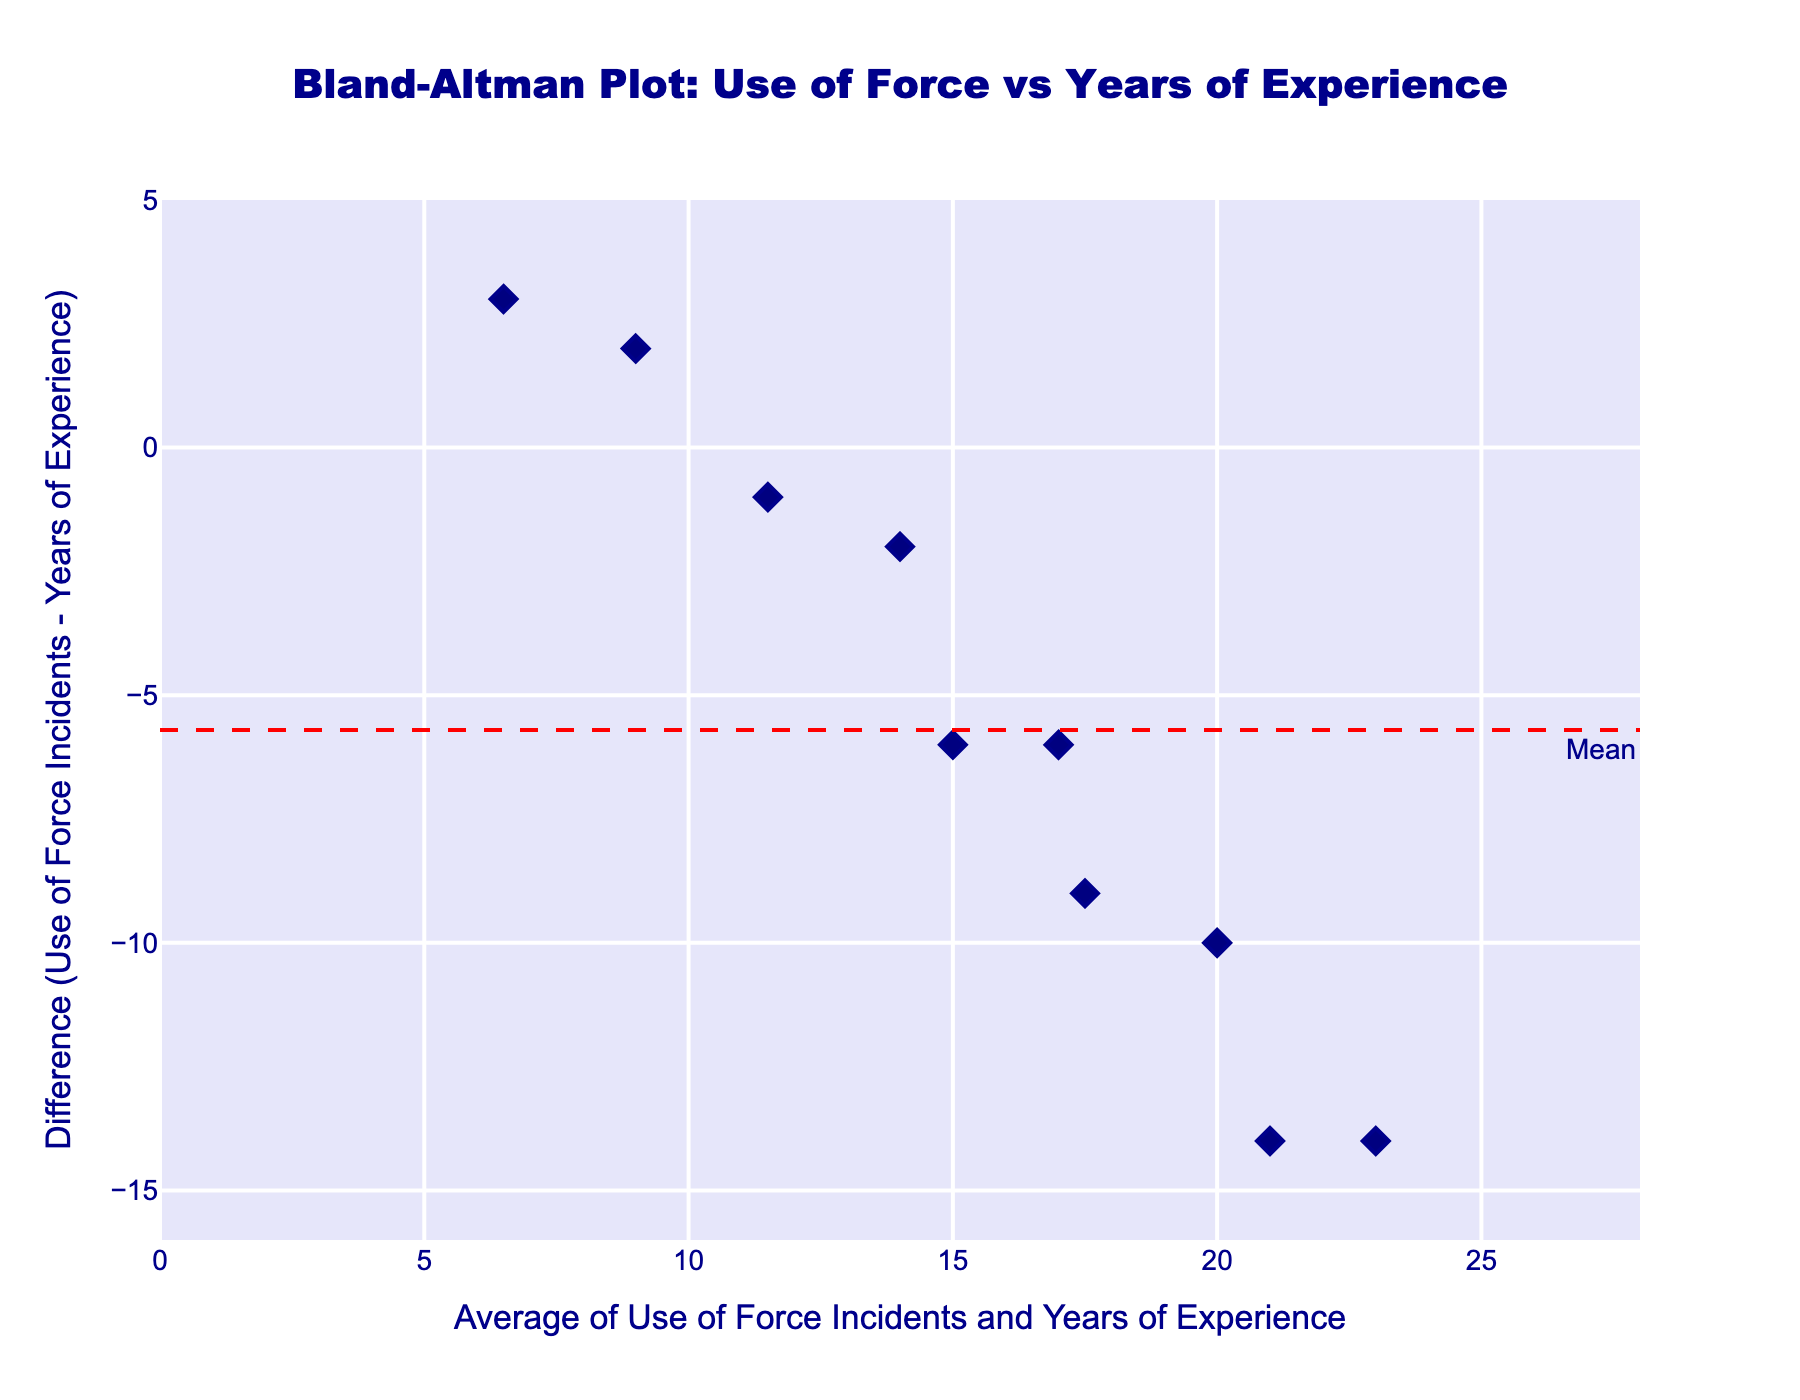1. What does the title of the plot indicate? The title reads "Bland-Altman Plot: Use of Force vs Years of Experience", indicating that the plot is used to compare the difference between use of force incidents and officers' years of experience.
Answer: Bland-Altman Plot: Use of Force vs Years of Experience 2. What are the x and y-axis titles? The x-axis title is "Average of Use of Force Incidents and Years of Experience", and the y-axis title is "Difference (Use of Force Incidents - Years of Experience)".
Answer: Average of Use of Force Incidents and Years of Experience; Difference (Use of Force Incidents - Years of Experience) 3. How many data points are plotted in the figure? There are 10 rows of data provided, which implies that there are 10 data points plotted on the figure.
Answer: 10 4. What is the mean difference line value? The red dashed line represents the mean difference, visually estimated at around 5.3 based on its position relative to the y-axis values.
Answer: About 5.3 5. What are the values of the limits of agreement lines? The limits of agreement are shown as green dotted lines with annotations, at around -1.9 SD and +12.5 SD, based on their positions on the y-axis.
Answer: About -1.9 SD and +12.5 SD 6. Which data point has the highest average value? The highest x-axis value represents the average of use of force incidents and years of experience. From the data, this corresponds to 23, (Average of (30 + 16) / 2).
Answer: 23 7. How many data points lie outside the limits of agreement? Counting the points above and below the annotated green dotted lines shows that none of the points lie outside the limits of agreement, all points are within the range.
Answer: 0 8. Which data point has the greatest difference in values? The y-axis shows the difference between use of force incidents and years of experience. The point at the highest point on the y-axis (around 10.5) corresponds to the data point with 5 years of experience and 8 use of force incidents, which has a difference of 3.
Answer: Point (5, 8) with a difference of about 10.5 9. What trend can be observed with increased years of experience regarding the difference in use of force incidents? Observing the trend of the points from left to right, as years of experience increase (larger x-axis values), the difference between use of force incidents and years of experience decreases towards the mean difference line.
Answer: Decreasing trend towards the mean 10. How does the Bland-Altman plot help in interpreting the correlation between use of force incidents and years of experience? The Bland-Altman plot visualizes the agreement between use of force incidents and years of experience by showing differences against the mean of the two measures. It helps to identify consistent bias and limits of agreement, indicating that while differences exist, they mostly fall within the acceptable range. This suggests a reasonable level of agreement without extreme outliers.
Answer: Shows agreement levels and bias 